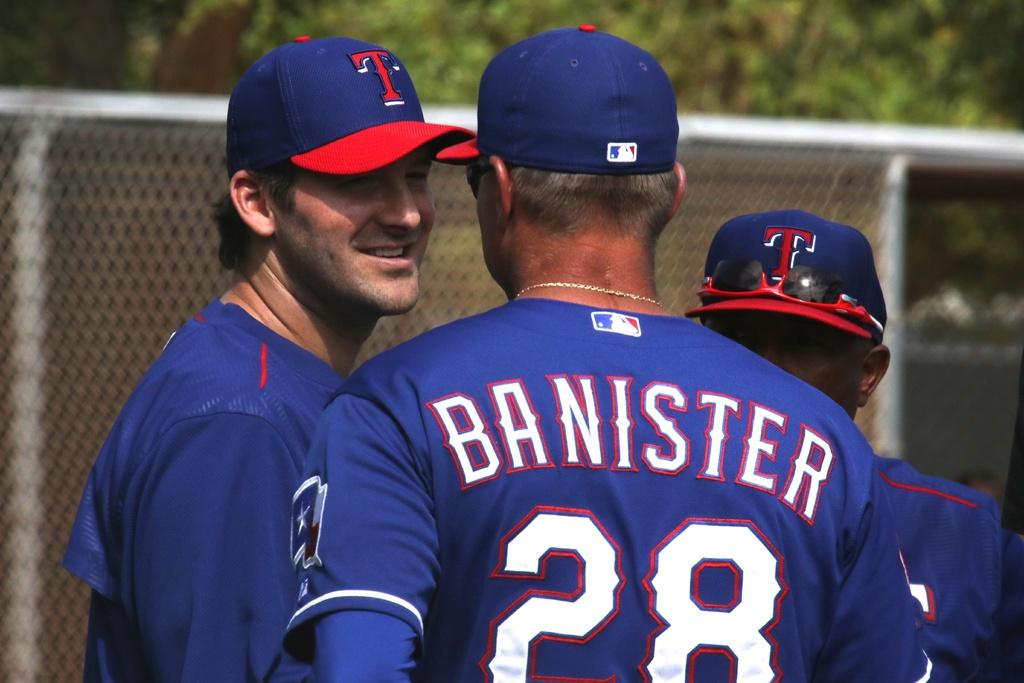<image>
Write a terse but informative summary of the picture. three men in blue shirts, one with the number 28 on the back. 